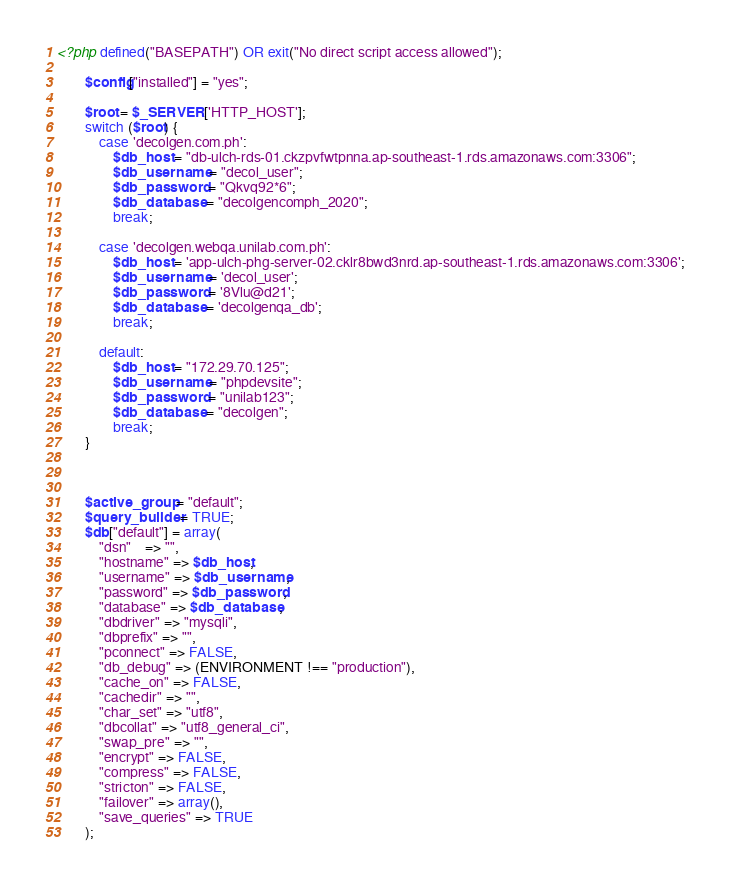Convert code to text. <code><loc_0><loc_0><loc_500><loc_500><_PHP_><?php defined("BASEPATH") OR exit("No direct script access allowed");

		$config["installed"] = "yes";

		$root = $_SERVER['HTTP_HOST'];
		switch ($root) {
			case 'decolgen.com.ph':
				$db_host = "db-ulch-rds-01.ckzpvfwtpnna.ap-southeast-1.rds.amazonaws.com:3306";
				$db_username = "decol_user";
				$db_password = "Qkvq92*6";
				$db_database = "decolgencomph_2020";
				break;

			case 'decolgen.webqa.unilab.com.ph':
				$db_host = 'app-ulch-phg-server-02.cklr8bwd3nrd.ap-southeast-1.rds.amazonaws.com:3306';
				$db_username = 'decol_user';
				$db_password = '8Vlu@d21';
				$db_database = 'decolgenqa_db';
				break;
			
			default:
				$db_host = "172.29.70.125";
				$db_username = "phpdevsite";
				$db_password = "unilab123";
				$db_database = "decolgen";
				break;
		}

		
		
		$active_group = "default";
		$query_builder = TRUE;
		$db["default"] = array(
			"dsn"	=> "",
			"hostname" => $db_host,
			"username" => $db_username,
			"password" => $db_password,
			"database" => $db_database,
			"dbdriver" => "mysqli",
			"dbprefix" => "",
			"pconnect" => FALSE,
			"db_debug" => (ENVIRONMENT !== "production"),
			"cache_on" => FALSE,
			"cachedir" => "",
			"char_set" => "utf8",
			"dbcollat" => "utf8_general_ci",
			"swap_pre" => "",
			"encrypt" => FALSE,
			"compress" => FALSE,
			"stricton" => FALSE,
			"failover" => array(),
			"save_queries" => TRUE
		);</code> 